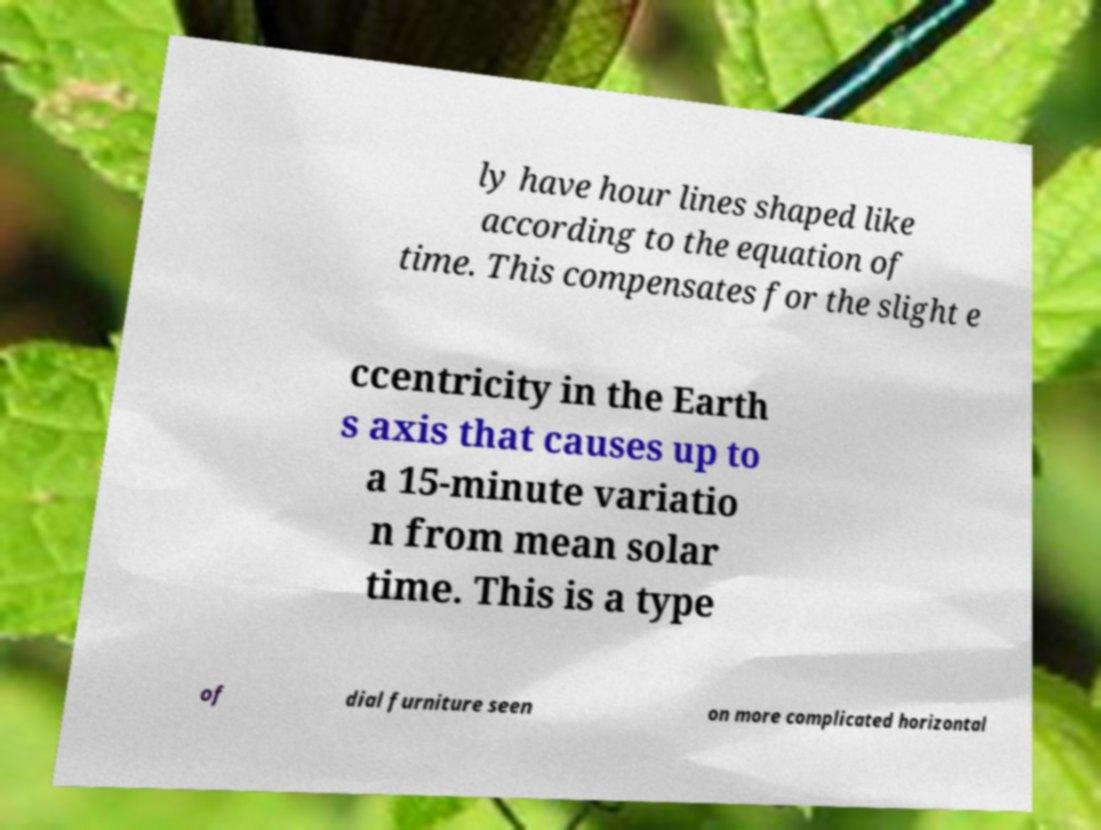What messages or text are displayed in this image? I need them in a readable, typed format. ly have hour lines shaped like according to the equation of time. This compensates for the slight e ccentricity in the Earth s axis that causes up to a 15-minute variatio n from mean solar time. This is a type of dial furniture seen on more complicated horizontal 